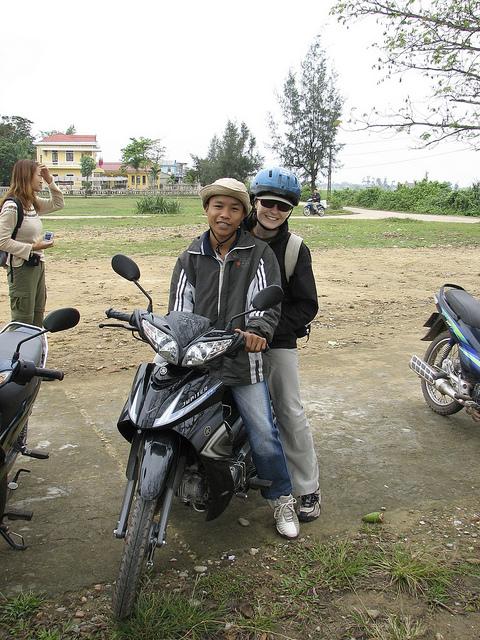How long have the people been riding the bike?
Short answer required. Few hours. What are they riding?
Give a very brief answer. Motorcycles. What color is the side view mirror?
Give a very brief answer. Black. 